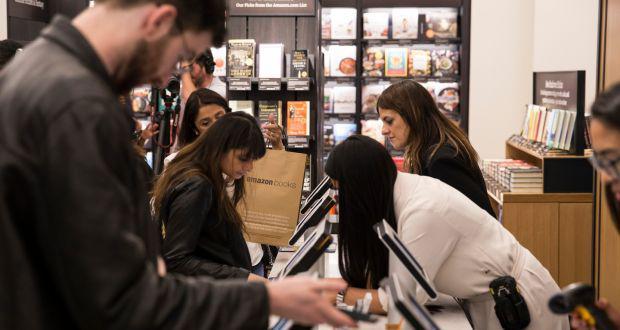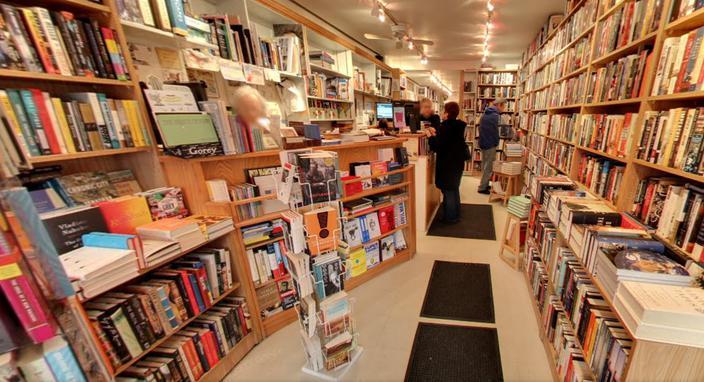The first image is the image on the left, the second image is the image on the right. Considering the images on both sides, is "In at least one image there is a female with long hair at the the cash register and at least three customers throughout the bookstore." valid? Answer yes or no. Yes. The first image is the image on the left, the second image is the image on the right. For the images displayed, is the sentence "The left image shows people standing on the left and right of a counter, with heads bent toward each other." factually correct? Answer yes or no. Yes. 